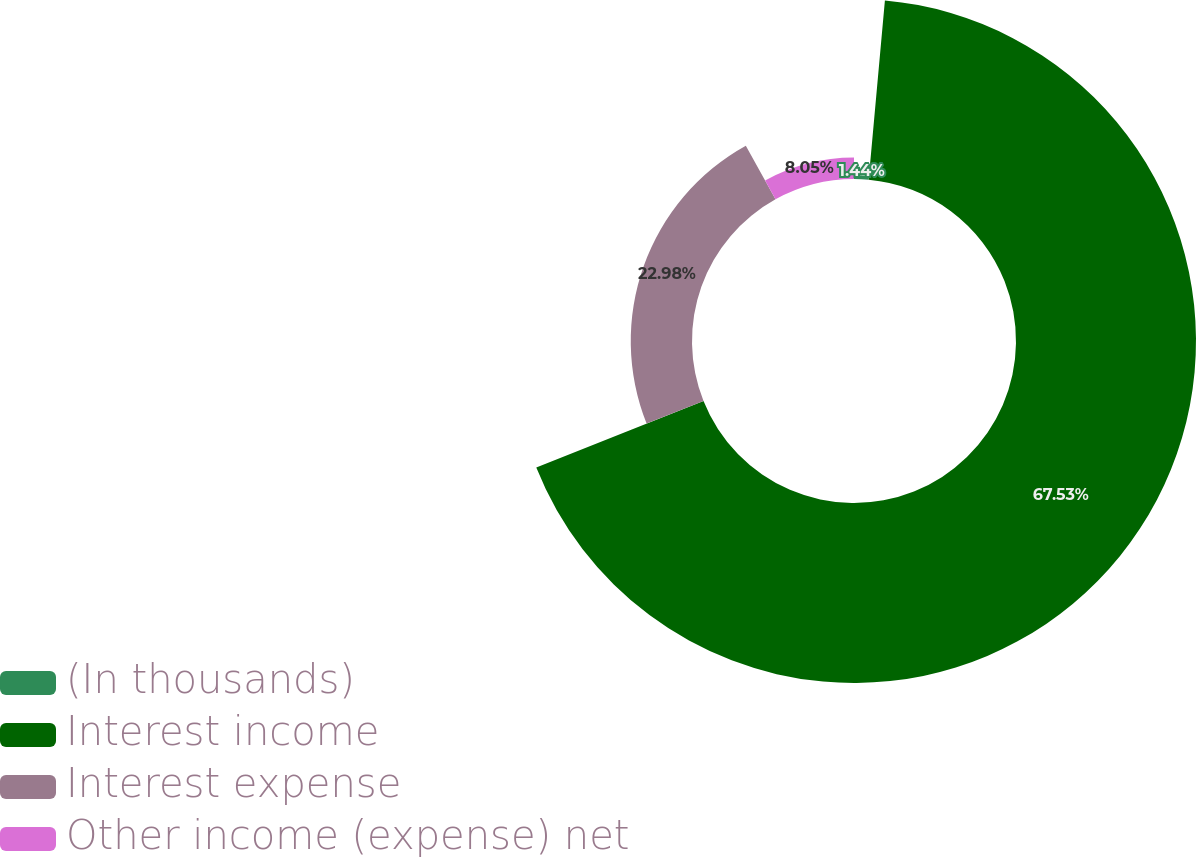Convert chart to OTSL. <chart><loc_0><loc_0><loc_500><loc_500><pie_chart><fcel>(In thousands)<fcel>Interest income<fcel>Interest expense<fcel>Other income (expense) net<nl><fcel>1.44%<fcel>67.52%<fcel>22.98%<fcel>8.05%<nl></chart> 